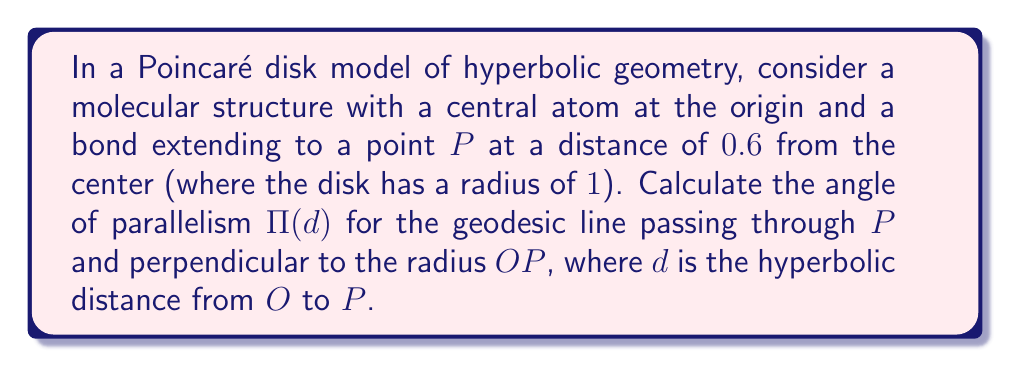Show me your answer to this math problem. Let's approach this step-by-step:

1) In the Poincaré disk model, the hyperbolic distance d from the center O to a point P at Euclidean distance r is given by:

   $$d = 2 \tanh^{-1}(r)$$

2) We're given that r = 0.6. Let's calculate d:

   $$d = 2 \tanh^{-1}(0.6)$$

3) Using a calculator or computer, we can evaluate this:

   $$d \approx 1.3169578969248166$$

4) The angle of parallelism Π(d) in hyperbolic geometry is related to the hyperbolic distance d by the formula:

   $$\Pi(d) = 2 \tan^{-1}(e^{-d})$$

5) Substituting our value of d:

   $$\Pi(d) = 2 \tan^{-1}(e^{-1.3169578969248166})$$

6) Evaluating this:

   $$\Pi(d) \approx 0.8410686705679303$$

7) This angle is in radians. To convert to degrees, multiply by 180/π:

   $$\Pi(d) \approx 0.8410686705679303 * \frac{180}{\pi} \approx 48.19°$$

This angle represents the angle between the geodesic line through P perpendicular to OP and the limiting parallel lines to this geodesic passing through O.
Answer: $\Pi(d) \approx 48.19°$ 